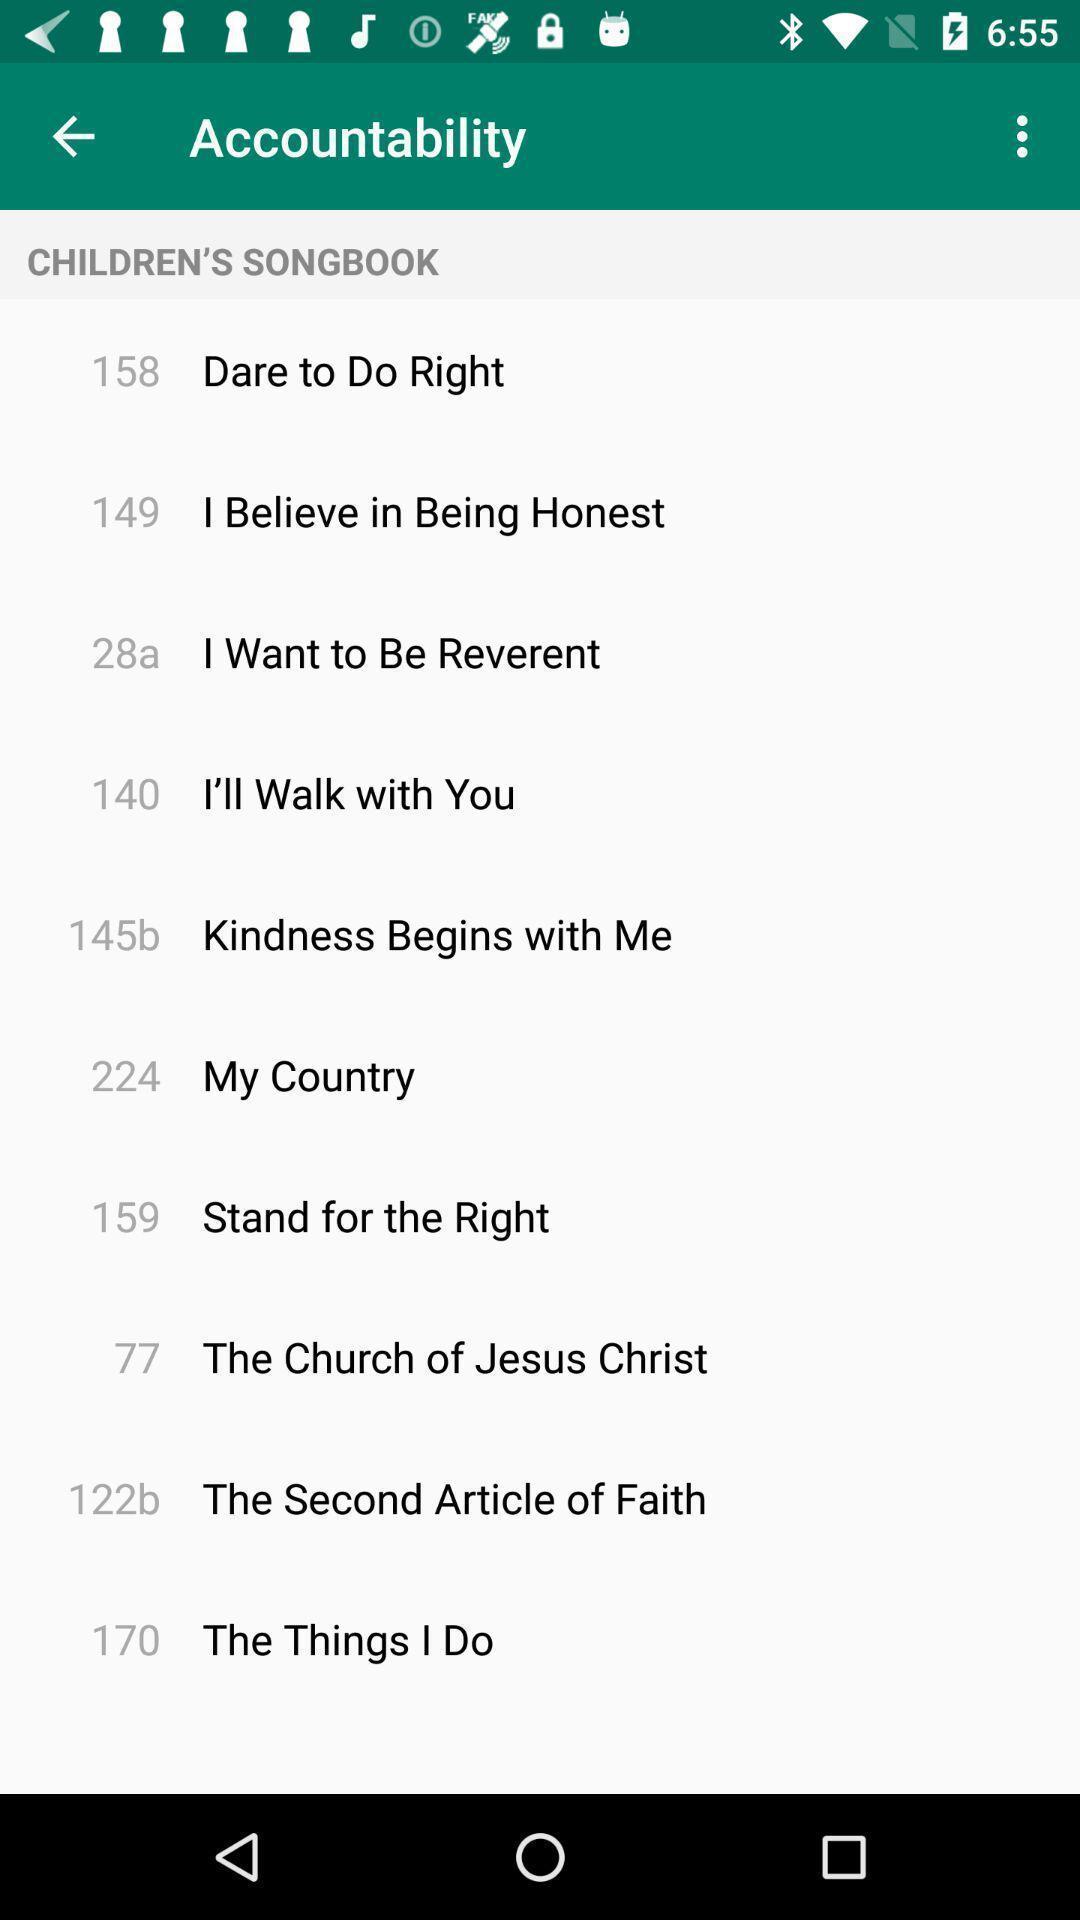Describe the visual elements of this screenshot. Screen shows accountability page in sacred music app. 